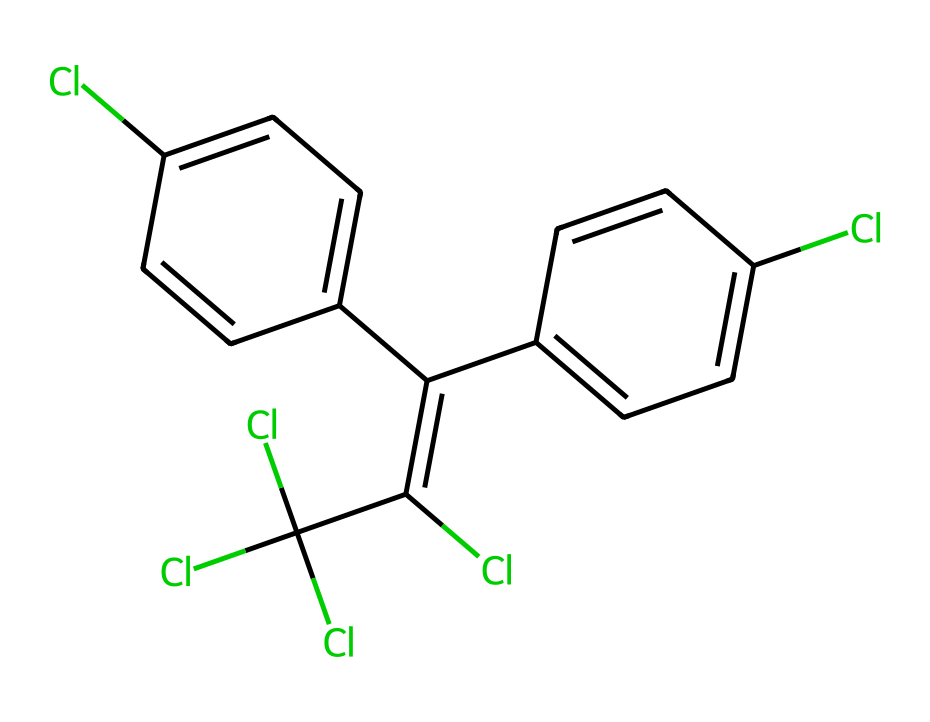What is the highest oxidation state of chlorine in this compound? The chlorine atoms in this structure are represented prominently, and the highest oxidation state for chlorine in organic compounds is typically +7. However, counting from the structure's chlorinated sections, we can directly observe that the chlorines attached to the carbon in both sides are in an oxidation state of -1. The other chlorine atoms attached to the carbon skeletons are also in the -1 oxidation state since they are not involved in any other complexes which would cause an increase.
Answer: -1 How many carbon atoms are present in this structure? By counting the carbon atoms directly in the given SMILES representation, there are 12 carbon atoms total. Each "C" in the SMILES denotes a carbon atom, and observing the branching gives a total count.
Answer: 12 What type of chemical structure is indicated by the presence of multiple chlorine atoms? The presence of multiple chlorine atoms suggests that this compound is a chlorinated aromatic compound. The structure exhibits characteristics where chlorine atoms are substituted on aromatic rings, typical of such compounds.
Answer: chlorinated aromatic Which part of the structure resembles estrogen in terms of functionality? The arrangement of the rings and the functional groups present in this chemical highlight a resemblance to the steroid nucleus associated with estrogen. This includes the presence of specific phenolic structures which can mimic estrogen activity.
Answer: rings How many phenyl rings are present in this compound? A phenyl ring is identified by its benzene (circular carbon structure with hydrogen substitutions). Here, two separate aromatic rings can be seen connected to a central structure which is indicative of phenol. By counting, there are two distinct phenyl groups evident in the overall structure.
Answer: 2 